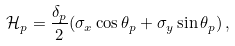Convert formula to latex. <formula><loc_0><loc_0><loc_500><loc_500>\mathcal { H } _ { p } = \frac { \delta _ { p } } { 2 } ( \sigma _ { x } \cos \theta _ { p } + \sigma _ { y } \sin \theta _ { p } ) \, ,</formula> 